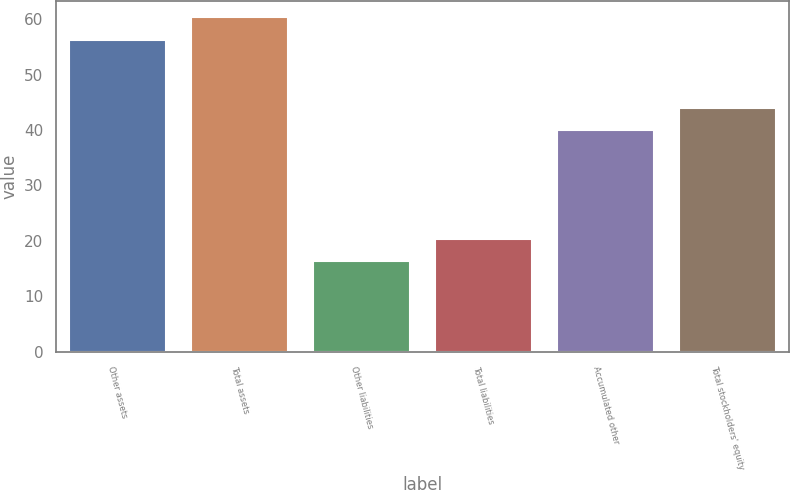Convert chart. <chart><loc_0><loc_0><loc_500><loc_500><bar_chart><fcel>Other assets<fcel>Total assets<fcel>Other liabilities<fcel>Total liabilities<fcel>Accumulated other<fcel>Total stockholders' equity<nl><fcel>56.3<fcel>60.3<fcel>16.3<fcel>20.3<fcel>40<fcel>44<nl></chart> 